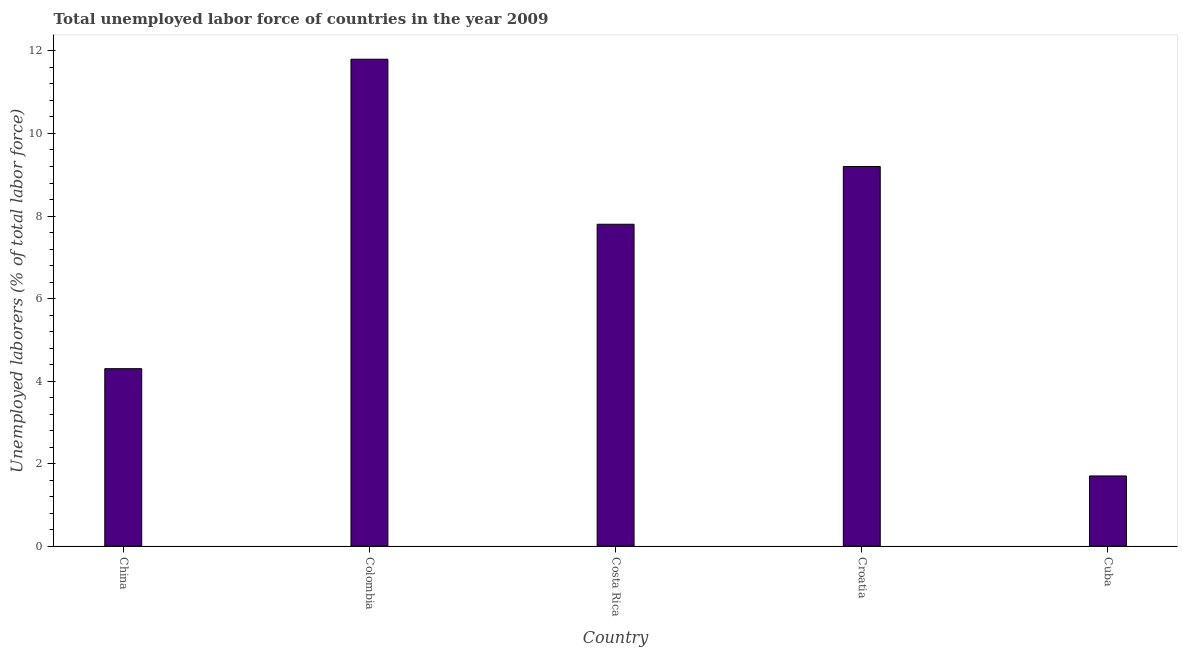Does the graph contain grids?
Your response must be concise. No. What is the title of the graph?
Your answer should be compact. Total unemployed labor force of countries in the year 2009. What is the label or title of the Y-axis?
Provide a short and direct response. Unemployed laborers (% of total labor force). What is the total unemployed labour force in Croatia?
Offer a terse response. 9.2. Across all countries, what is the maximum total unemployed labour force?
Ensure brevity in your answer.  11.8. Across all countries, what is the minimum total unemployed labour force?
Ensure brevity in your answer.  1.7. In which country was the total unemployed labour force minimum?
Make the answer very short. Cuba. What is the sum of the total unemployed labour force?
Give a very brief answer. 34.8. What is the average total unemployed labour force per country?
Your answer should be very brief. 6.96. What is the median total unemployed labour force?
Make the answer very short. 7.8. In how many countries, is the total unemployed labour force greater than 2.4 %?
Your response must be concise. 4. What is the ratio of the total unemployed labour force in Croatia to that in Cuba?
Keep it short and to the point. 5.41. Is the sum of the total unemployed labour force in Croatia and Cuba greater than the maximum total unemployed labour force across all countries?
Give a very brief answer. No. In how many countries, is the total unemployed labour force greater than the average total unemployed labour force taken over all countries?
Offer a terse response. 3. What is the difference between two consecutive major ticks on the Y-axis?
Provide a short and direct response. 2. What is the Unemployed laborers (% of total labor force) in China?
Your answer should be compact. 4.3. What is the Unemployed laborers (% of total labor force) in Colombia?
Offer a very short reply. 11.8. What is the Unemployed laborers (% of total labor force) of Costa Rica?
Your response must be concise. 7.8. What is the Unemployed laborers (% of total labor force) in Croatia?
Give a very brief answer. 9.2. What is the Unemployed laborers (% of total labor force) in Cuba?
Offer a terse response. 1.7. What is the difference between the Unemployed laborers (% of total labor force) in China and Croatia?
Offer a terse response. -4.9. What is the difference between the Unemployed laborers (% of total labor force) in China and Cuba?
Your response must be concise. 2.6. What is the difference between the Unemployed laborers (% of total labor force) in Colombia and Croatia?
Your response must be concise. 2.6. What is the difference between the Unemployed laborers (% of total labor force) in Costa Rica and Croatia?
Provide a succinct answer. -1.4. What is the difference between the Unemployed laborers (% of total labor force) in Costa Rica and Cuba?
Your answer should be very brief. 6.1. What is the difference between the Unemployed laborers (% of total labor force) in Croatia and Cuba?
Keep it short and to the point. 7.5. What is the ratio of the Unemployed laborers (% of total labor force) in China to that in Colombia?
Make the answer very short. 0.36. What is the ratio of the Unemployed laborers (% of total labor force) in China to that in Costa Rica?
Ensure brevity in your answer.  0.55. What is the ratio of the Unemployed laborers (% of total labor force) in China to that in Croatia?
Provide a succinct answer. 0.47. What is the ratio of the Unemployed laborers (% of total labor force) in China to that in Cuba?
Offer a very short reply. 2.53. What is the ratio of the Unemployed laborers (% of total labor force) in Colombia to that in Costa Rica?
Provide a short and direct response. 1.51. What is the ratio of the Unemployed laborers (% of total labor force) in Colombia to that in Croatia?
Ensure brevity in your answer.  1.28. What is the ratio of the Unemployed laborers (% of total labor force) in Colombia to that in Cuba?
Your answer should be very brief. 6.94. What is the ratio of the Unemployed laborers (% of total labor force) in Costa Rica to that in Croatia?
Give a very brief answer. 0.85. What is the ratio of the Unemployed laborers (% of total labor force) in Costa Rica to that in Cuba?
Make the answer very short. 4.59. What is the ratio of the Unemployed laborers (% of total labor force) in Croatia to that in Cuba?
Provide a short and direct response. 5.41. 